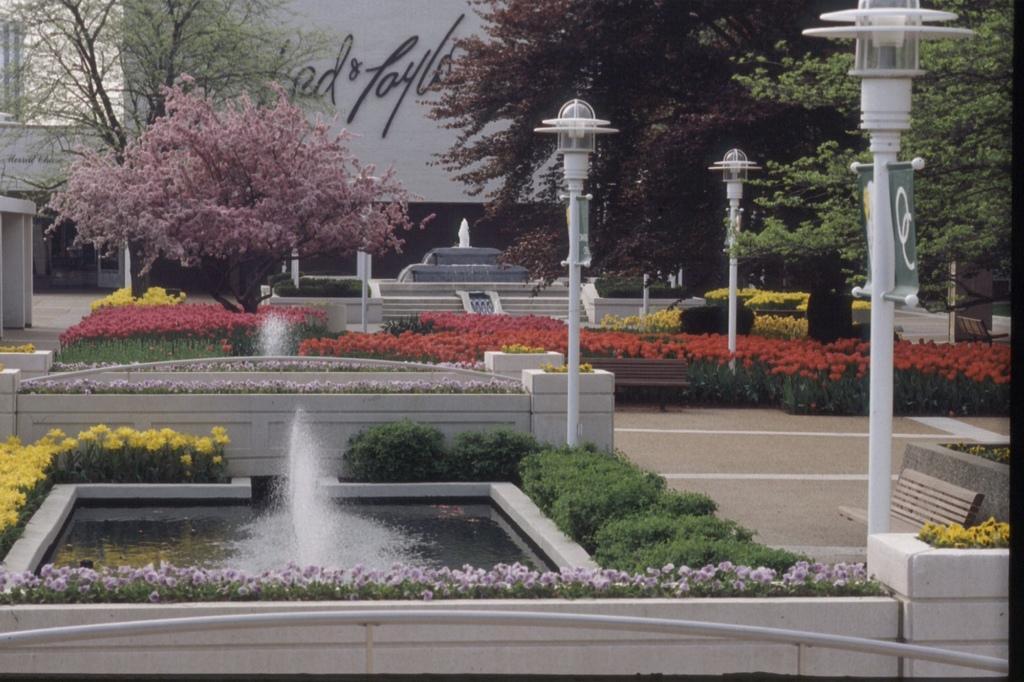Describe this image in one or two sentences. In this image I can see few fountain,trees,light poles and building. I can see few yellow,red and pink flowers and few benches. 